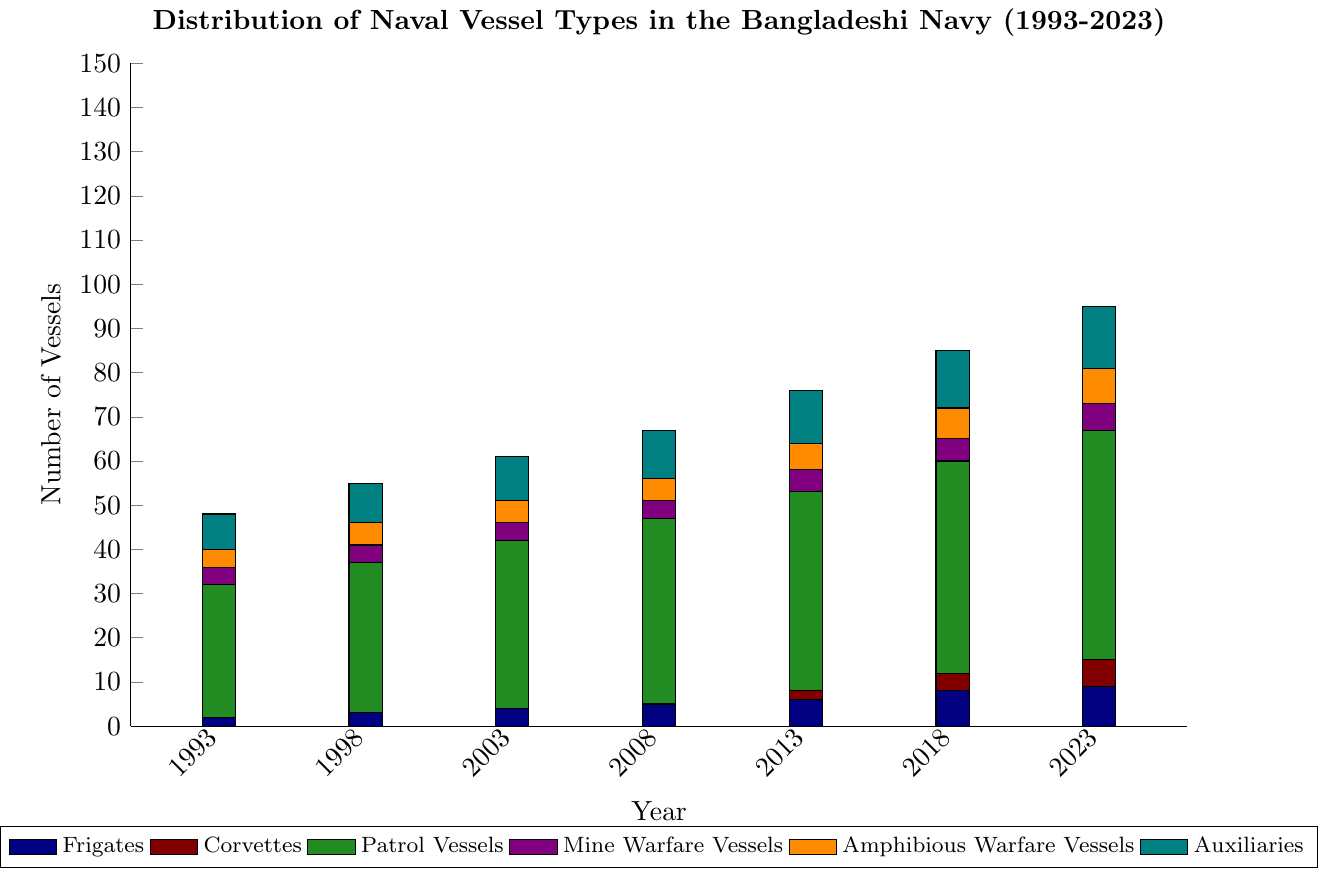What year had the highest number of corvettes? The corvette bars are non-existent until 2013, and they continue to increase afterward. The tallest bar for corvettes appears in 2023.
Answer: 2023 How many total naval vessels were there in 2008? To find the total number of naval vessels in 2008, sum each vessel type for that year: 5 (frigates) + 0 (corvettes) + 42 (patrol vessels) + 4 (mine warfare vessels) + 5 (amphibious warfare vessels) + 11 (auxiliaries) = 67.
Answer: 67 Which vessel type had the largest increase in number from 1993 to 2023? Compare the increase for each vessel type: frigates (9-2=7), corvettes (6-0=6), patrol vessels (52-30=22), mine warfare vessels (6-4=2), amphibious warfare vessels (8-4=4), auxiliaries (14-8=6). Patrol vessels have the largest increase.
Answer: Patrol Vessels In which year did amphibious warfare vessels first outnumber mine warfare vessels? From visual inspection, look for the first year where the orange bars (amphibious warfare vessels) are taller than the purple bars (mine warfare vessels). This occurs in 1998.
Answer: 1998 Compare the number of auxiliaries in 1993 and 2023. Which year had more? From the chart, count the height of the teal bars for both years. In 1993, there are 8 auxiliaries; in 2023, there are 14 auxiliaries. Thus, 2023 had more.
Answer: 2023 How did the number of frigates change from 2003 to 2013? The number of frigates in 2003 is 4 and in 2013 is 6. The change is calculated by subtracting the earlier value from the later value, 6 - 4 = 2.
Answer: 2 What is the total number of mine warfare vessels in the years where corvettes were not present? First, identify the years with no corvettes: 1993, 1998, 2003, 2008. Sum the number of mine warfare vessels in these years: 4 (1993) + 4 (1998) + 4 (2003) + 4 (2008) = 16.
Answer: 16 In 2018, were there more frigates or corvettes? By how many? In 2018, the number of frigates is 8 and corvettes is 4. The difference is calculated by 8 - 4 = 4.
Answer: Frigates by 4 Which vessel type had the smallest numerical change from 1993 to 2023? Compare the numerical changes: frigates (9-2=7), corvettes (6-0=6), patrol vessels (52-30=22), mine warfare vessels (6-4=2), amphibious warfare vessels (8-4=4), auxiliaries (14-8=6). Mine warfare vessels had the smallest change.
Answer: Mine Warfare Vessels How many more patrol vessels were there in 2023 compared to 2013? The number of patrol vessels in 2023 is 52 and in 2013 it's 45. The difference: 52 - 45 = 7.
Answer: 7 